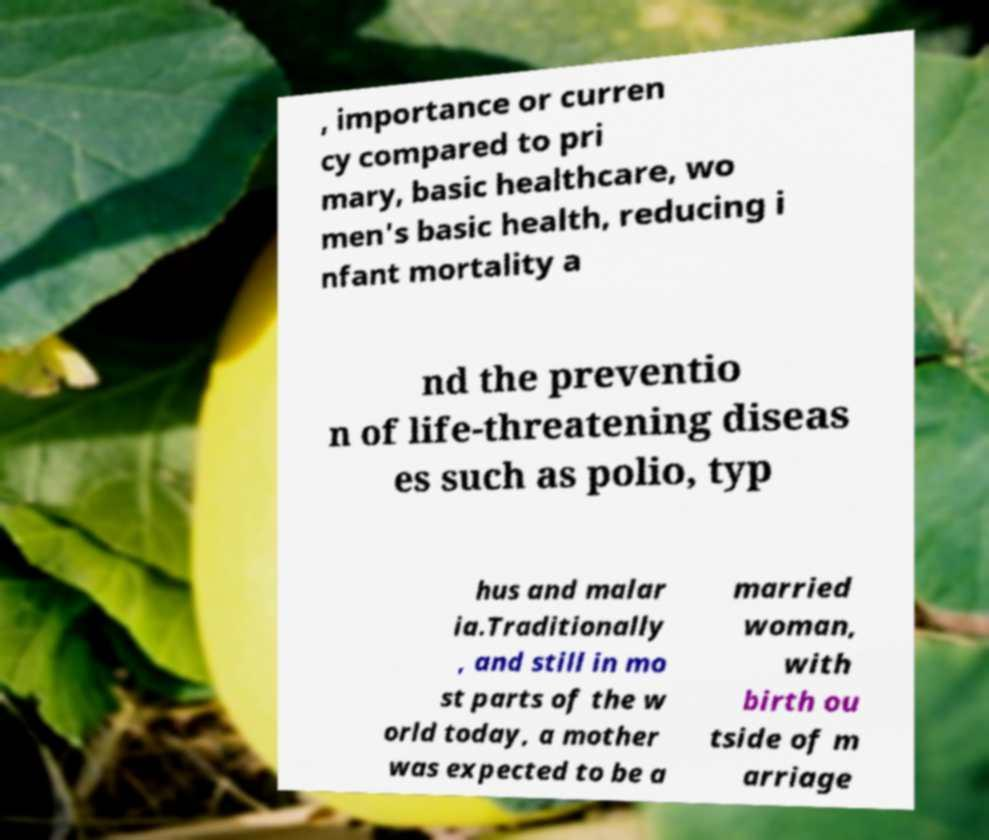What messages or text are displayed in this image? I need them in a readable, typed format. , importance or curren cy compared to pri mary, basic healthcare, wo men's basic health, reducing i nfant mortality a nd the preventio n of life-threatening diseas es such as polio, typ hus and malar ia.Traditionally , and still in mo st parts of the w orld today, a mother was expected to be a married woman, with birth ou tside of m arriage 